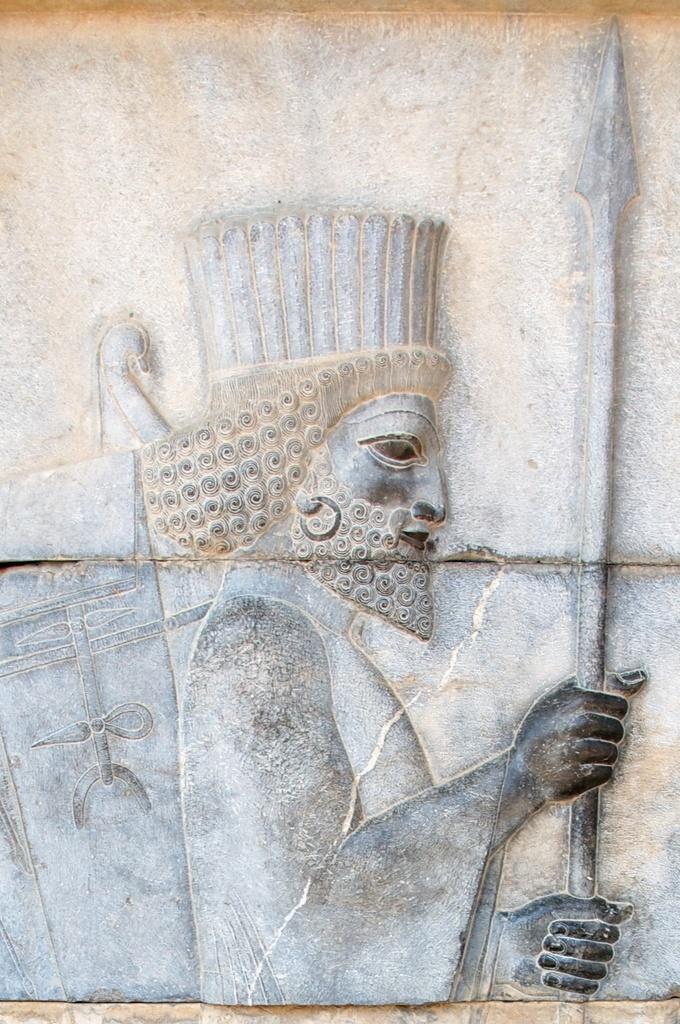Could you give a brief overview of what you see in this image? We can see carving on the wall. 